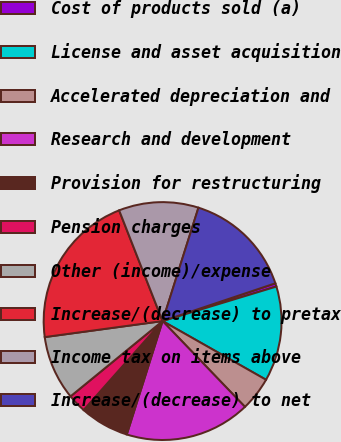Convert chart to OTSL. <chart><loc_0><loc_0><loc_500><loc_500><pie_chart><fcel>Cost of products sold (a)<fcel>License and asset acquisition<fcel>Accelerated depreciation and<fcel>Research and development<fcel>Provision for restructuring<fcel>Pension charges<fcel>Other (income)/expense<fcel>Increase/(decrease) to pretax<fcel>Income tax on items above<fcel>Increase/(decrease) to net<nl><fcel>0.46%<fcel>12.9%<fcel>4.61%<fcel>17.05%<fcel>6.68%<fcel>2.54%<fcel>8.76%<fcel>21.2%<fcel>10.83%<fcel>14.98%<nl></chart> 